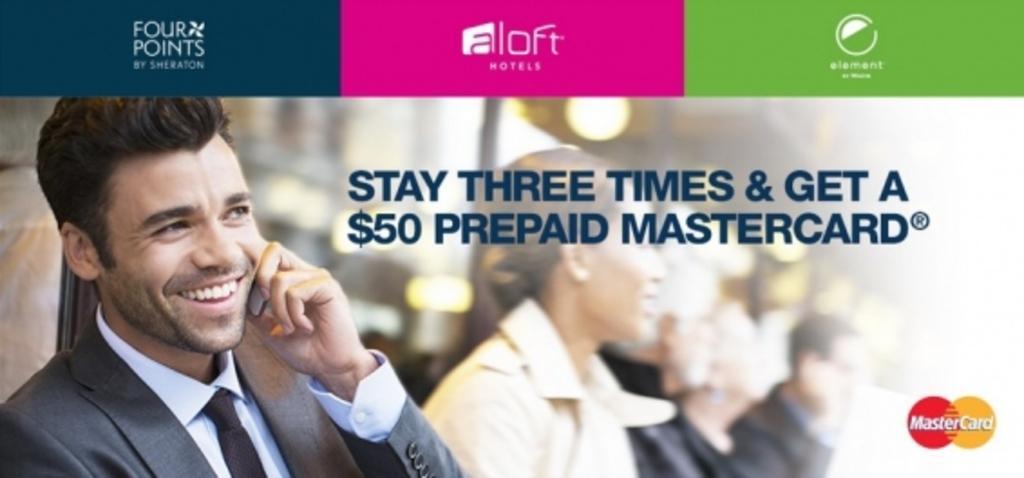Please provide a concise description of this image. On the left side of the image we can see a man smiling and holding a mobile in his hand, next to him there are people. 